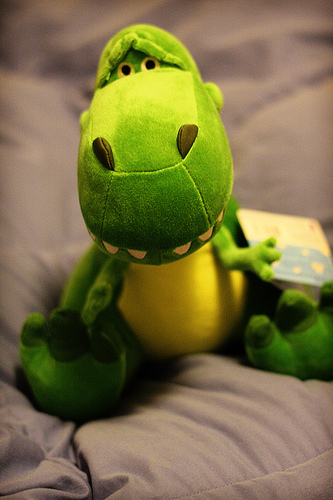<image>
Is there a toy on the bed? Yes. Looking at the image, I can see the toy is positioned on top of the bed, with the bed providing support. 